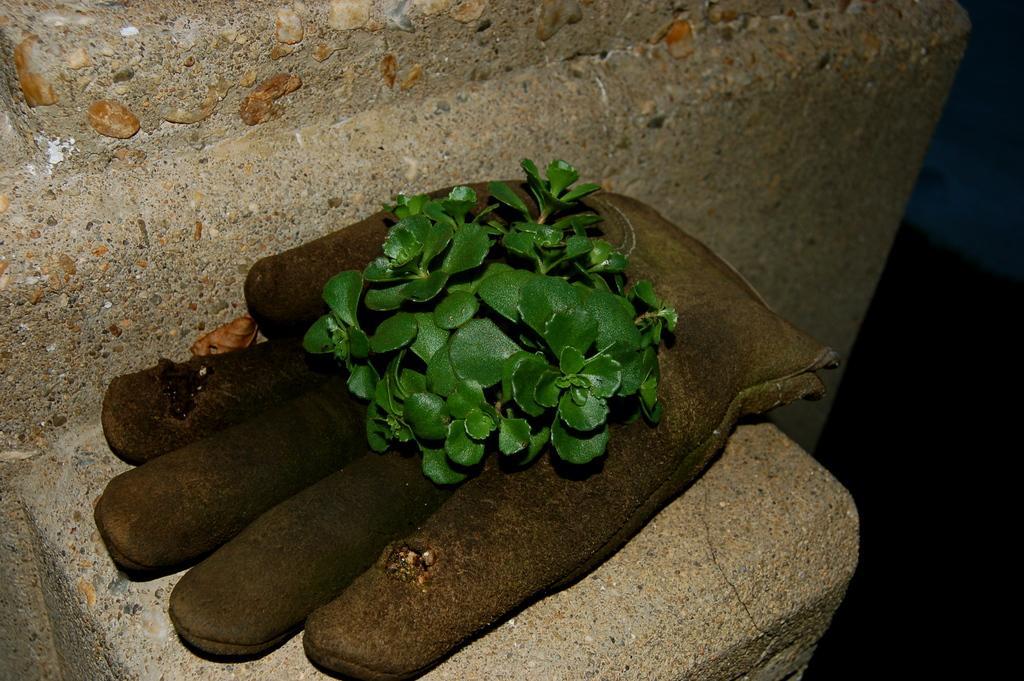Could you give a brief overview of what you see in this image? In this picture we can see a plant on an object and in the background we can see wall. 